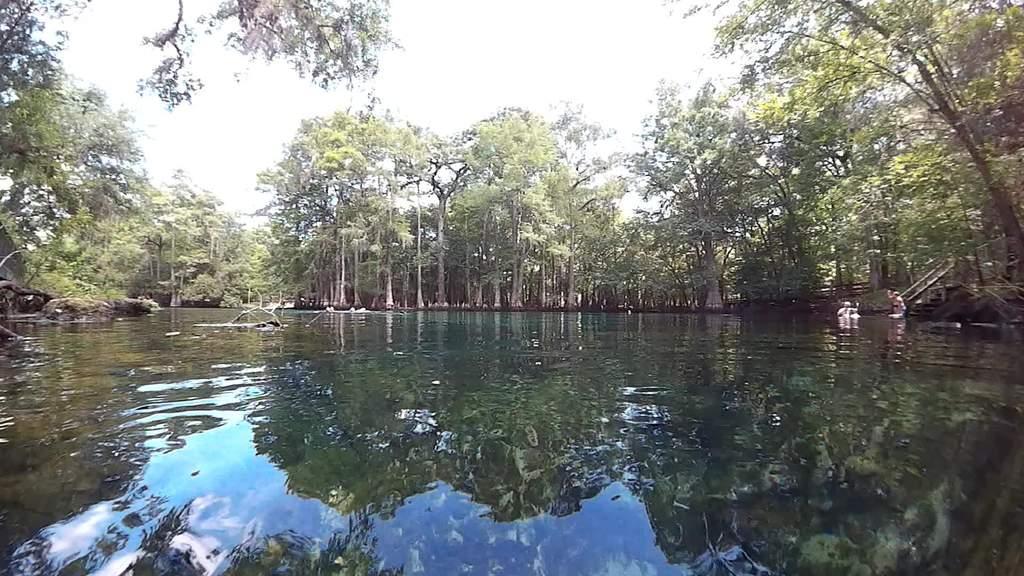Could you give a brief overview of what you see in this image? In this picture there are trees. On the right side of the image there is a wooden staircase and there are two persons in the water. At the top there is sky. At the bottom there is water and there is a reflection of tree and sky on the water. 